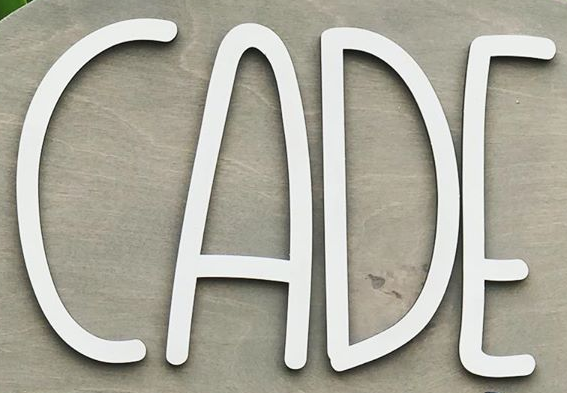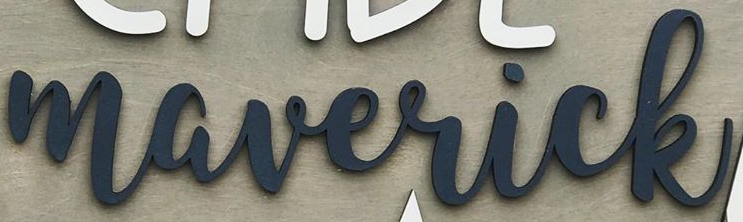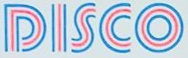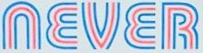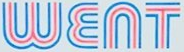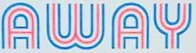Transcribe the words shown in these images in order, separated by a semicolon. ACDE; maverick; DISCO; NEVER; WENT; AWAY 